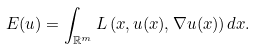<formula> <loc_0><loc_0><loc_500><loc_500>E ( u ) = \int _ { \mathbb { R } ^ { m } } L \left ( x , u ( x ) , \nabla u ( x ) \right ) d x .</formula> 